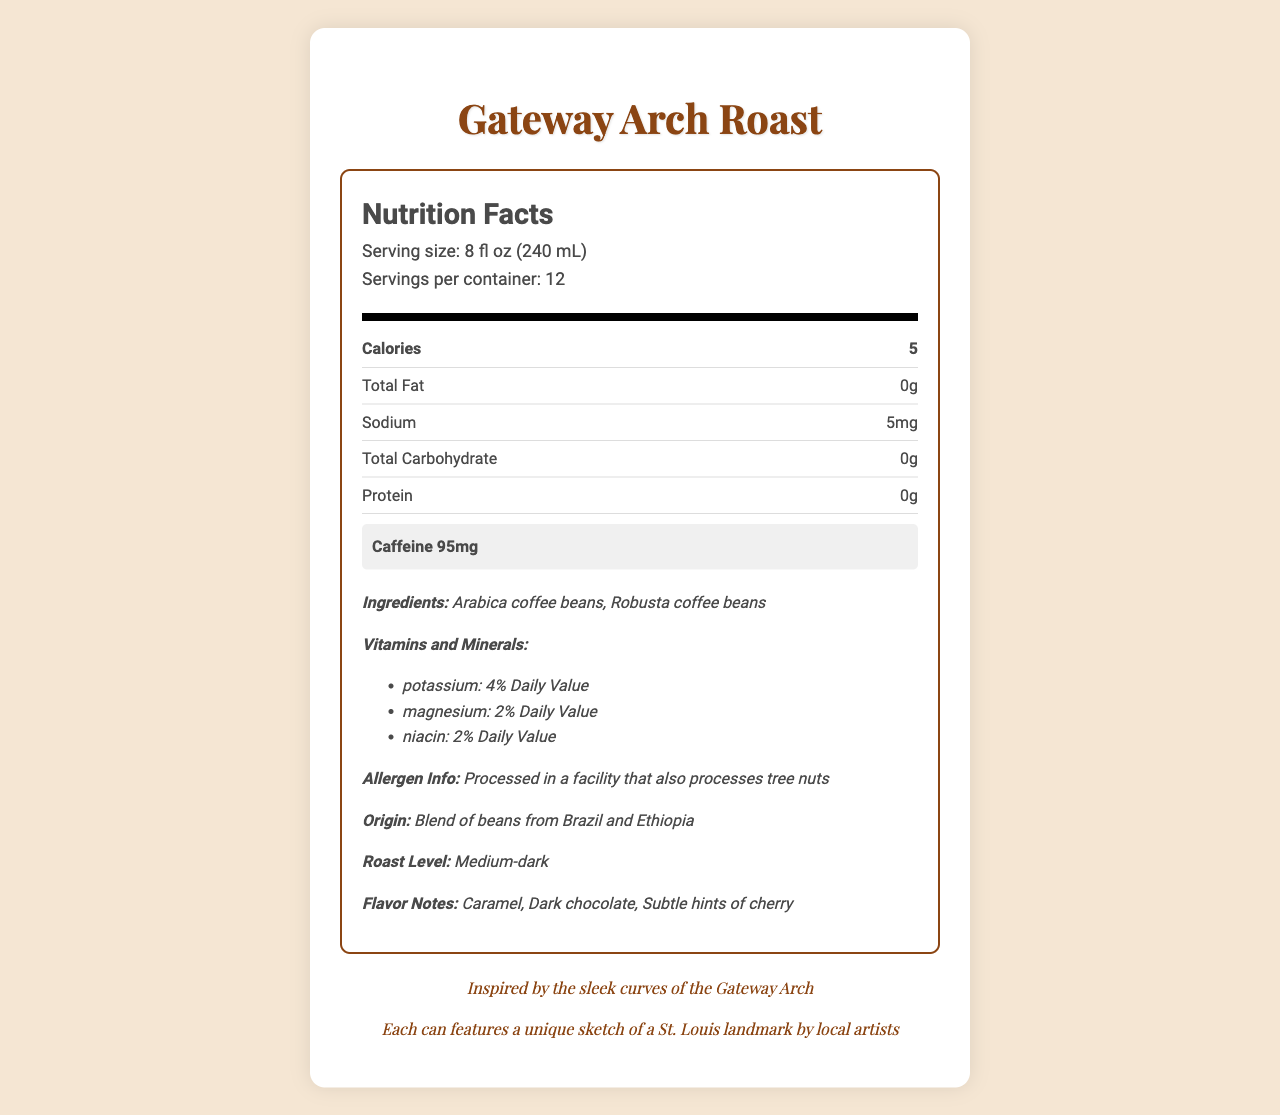what is the product name? The product name is prominently displayed at the top of the nutrition facts document.
Answer: Gateway Arch Roast what is the serving size? The serving size details are listed under the serving information section in the nutrition facts.
Answer: 8 fl oz (240 mL) how many calories are in one serving? The number of calories per serving is listed in the nutrition facts, specifically under "Calories".
Answer: 5 how much caffeine is in one serving? The caffeine content is highlighted in a special section of the nutrition label, making it easy to find.
Answer: 95 mg what types of coffee beans are used? The ingredients section lists Arabica coffee beans and Robusta coffee beans.
Answer: Arabica and Robusta coffee beans which vitamins and minerals are included in the coffee blend? A. Vitamin C B. Potassium C. Calcium D. Magnesium Potassium (4% Daily Value) and Magnesium (2% Daily Value) are specified in the vitamins and minerals section.
Answer: B and D What is the roast level of this coffee blend? A. Light B. Medium C. Medium-dark D. Dark The roast level is mentioned as "Medium-dark" in the additional information section.
Answer: C is there any allergen information provided? The document states that the product is processed in a facility that also processes tree nuts, indicating allergen information.
Answer: Yes Are the beans ethically sourced? The additional information mentions that the beans are ethically sourced.
Answer: Yes describe the flavor notes of the coffee blend. The flavor notes are listed as "Caramel," "Dark chocolate," and "Subtle hints of cherry" in the document.
Answer: Caramel, Dark chocolate, Subtle hints of cherry where are the coffee beans sourced from? The origin section specifies that the coffee beans are a blend from Brazil and Ethiopia.
Answer: Brazil and Ethiopia how long is the coffee best if used after opening? The shelf life details mention that the coffee is best if used within 2 weeks of opening.
Answer: 2 weeks what is the inspiration behind this coffee blend? The inspiration section talks about how the blend is inspired by the sleek curves of the Gateway Arch.
Answer: Inspired by the sleek curves of the Gateway Arch what type of packaging does the coffee come in? The packaging section describes it as a recyclable steel can reminiscent of the Eads Bridge.
Answer: Recyclable steel can, reminiscent of the Eads Bridge what is the suggested brewing instruction? The brewing instructions recommend using 2 tablespoons of ground coffee per 6 oz of water.
Answer: Use 2 tablespoons of ground coffee per 6 oz of water what is the significance of the artist note? The artist note mentions that each can features a unique sketch of a St. Louis landmark by local artists.
Answer: Features a unique sketch of a St. Louis landmark by local artists how many servings are there per container? The serving information mentions that there are 12 servings per container.
Answer: 12 what is the main focus of this document? The document mainly provides information about the nutritional facts, ingredients, caffeine content, and additional details of the Gateway Arch Roast coffee blend.
Answer: Nutritional facts, ingredients, caffeine content, and additional information about the Gateway Arch Roast coffee blend why might the caffeine content be important to note for artists? The document highlights the caffeine content, noting the coffee's potential to fuel artistic work, which could be important for artists seeking a pick-me-up.
Answer: It mentions that the coffee is "Perfect for fueling your artistic endeavors" how many grams of protein does one serving contain? The nutrition facts list protein content as 0 grams per serving.
Answer: 0 when is the coffee best used by? The shelf life section states that the coffee is best if used within 2 weeks of opening.
Answer: Best if used within 2 weeks of opening is this coffee decaffeinated? The document lists the caffeine content as 95 mg per serving, indicating it is not decaffeinated.
Answer: No does the document provide information on the environmental impact of the packaging? The packaging description mentions that it is a recyclable steel can, indicating some consideration of environmental impact.
Answer: Recyclable steel can how much sodium is in each serving? The nutrition facts indicate that there are 5 mg of sodium per serving.
Answer: 5 mg 